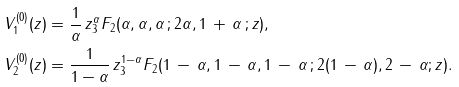<formula> <loc_0><loc_0><loc_500><loc_500>V _ { 1 } ^ { ( 0 ) } ( z ) & = \frac { 1 } { \alpha } \, z ^ { \alpha } _ { 3 } F _ { 2 } ( \alpha , \alpha , \alpha \, ; 2 \alpha , 1 \, + \, \alpha \, ; z ) , \\ V _ { 2 } ^ { ( 0 ) } ( z ) & = \frac { 1 } { 1 - \alpha } \, z ^ { 1 - \alpha } _ { 3 } F _ { 2 } ( 1 \, - \, \alpha , 1 \, - \, \alpha , 1 \, - \, \alpha \, ; 2 ( 1 \, - \, \alpha ) , 2 \, - \, \alpha ; z ) .</formula> 